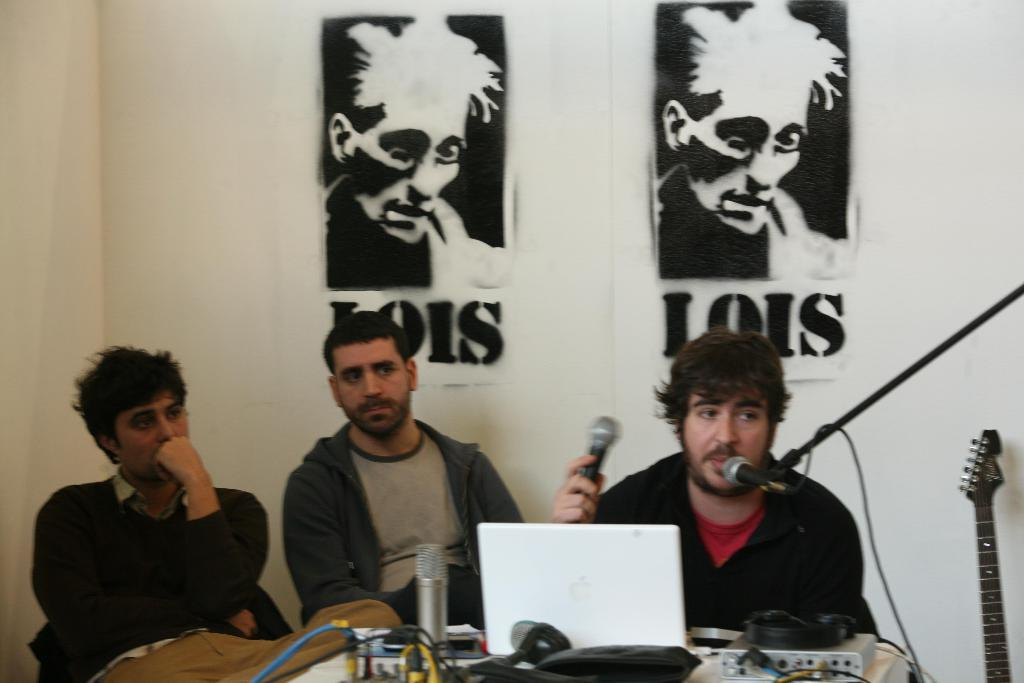What are the men in the image doing? The men are sitting in the center of the image. What is in front of the men? The men are in front of a table. What is on the table? The table contains a laptop and microphones (mics). Are there any additional items on the table? Yes, there are wires on the table. What can be seen on the wall in the image? There are sketches on the wall. What type of plant is growing on the table in the image? There is no plant growing on the table in the image; it contains a laptop, microphones, and wires. What kind of bread is being served to the men in the image? There is no bread present in the image. 